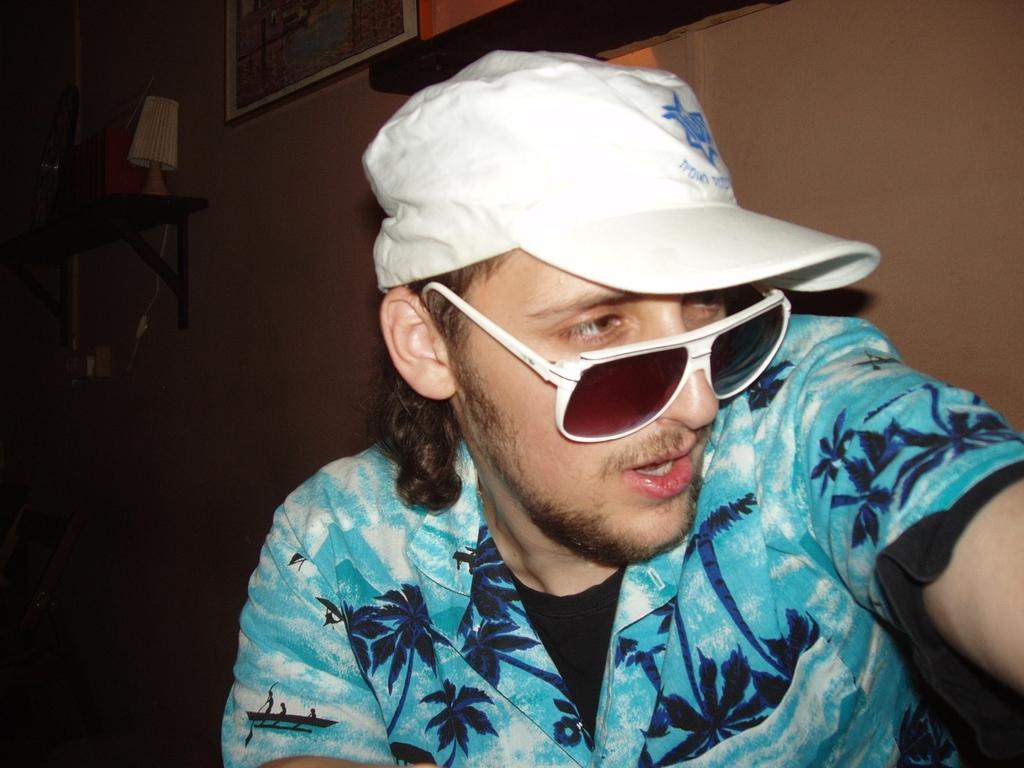In one or two sentences, can you explain what this image depicts? In this image there is a man sitting wearing glasses and a cap, in the background there is a wall for that wall there are photo frames and a board, on that there are few objects. 